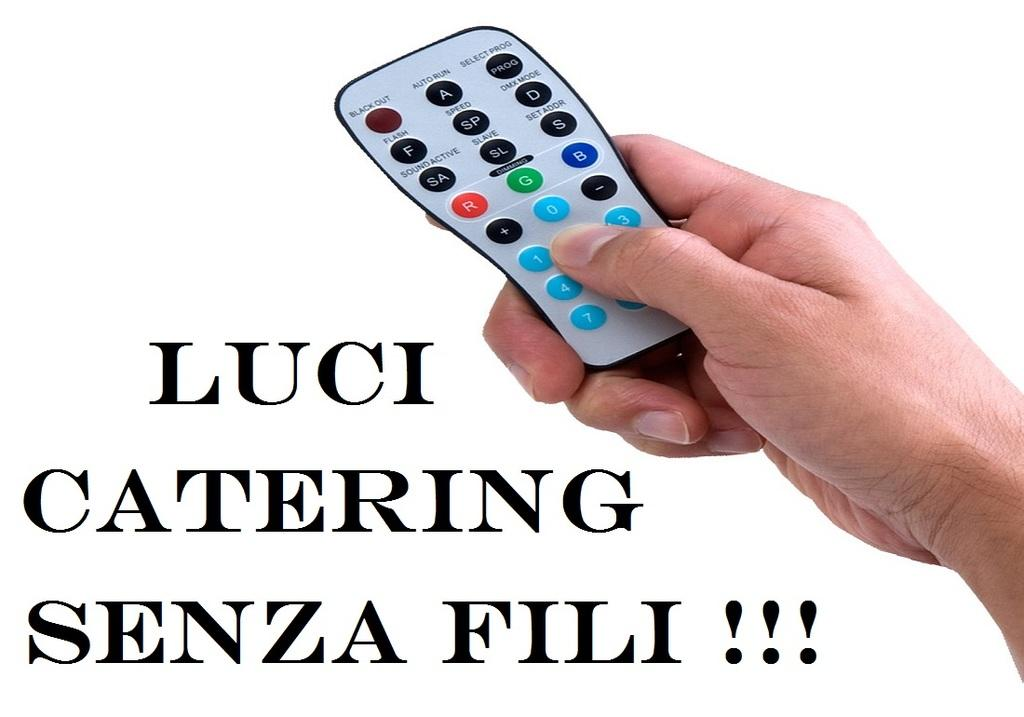<image>
Summarize the visual content of the image. a person is holding a remote on an advertisement taht says LUCI catering 